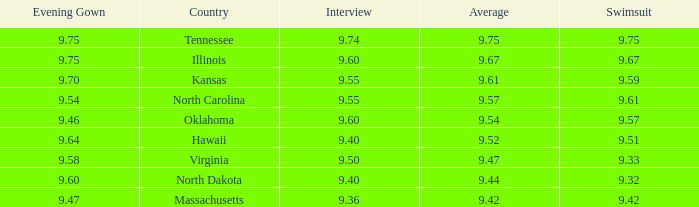67? Illinois. 